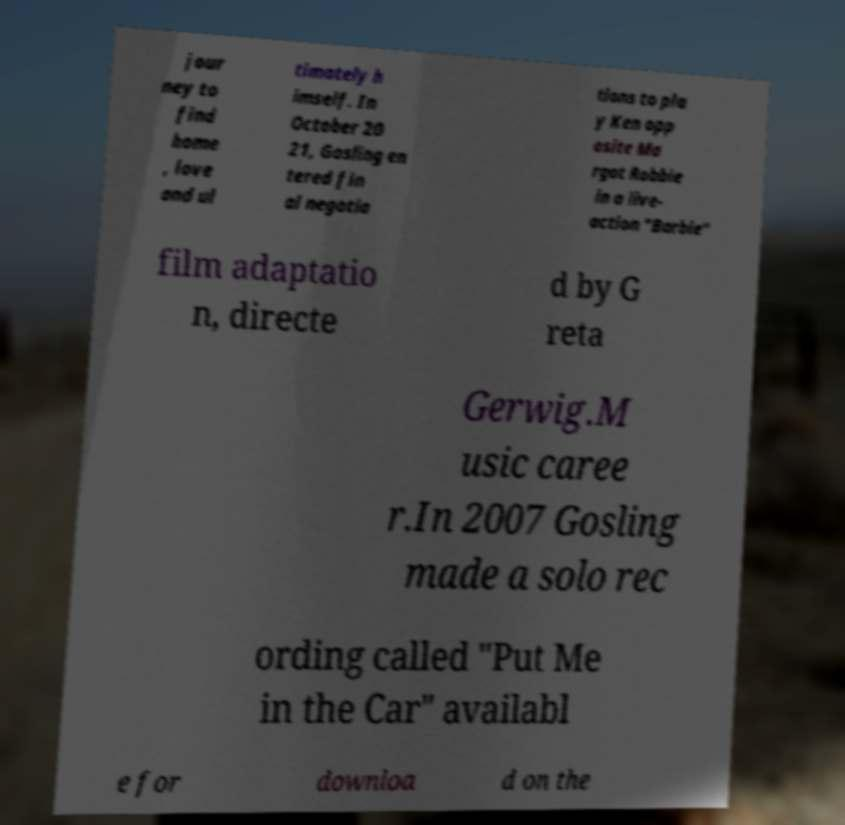Can you accurately transcribe the text from the provided image for me? jour ney to find home , love and ul timately h imself. In October 20 21, Gosling en tered fin al negotia tions to pla y Ken opp osite Ma rgot Robbie in a live- action "Barbie" film adaptatio n, directe d by G reta Gerwig.M usic caree r.In 2007 Gosling made a solo rec ording called "Put Me in the Car" availabl e for downloa d on the 